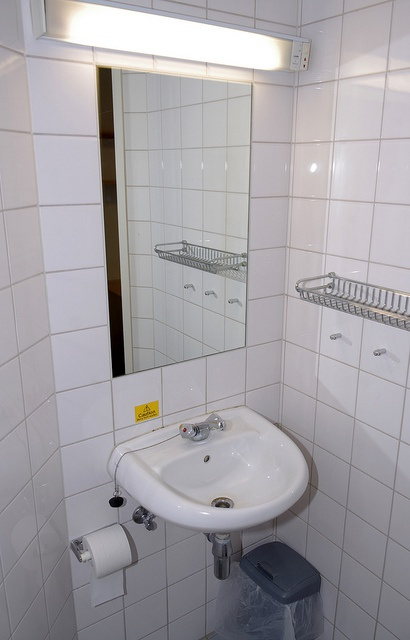Describe the objects in this image and their specific colors. I can see a sink in gray, darkgray, and lightgray tones in this image. 